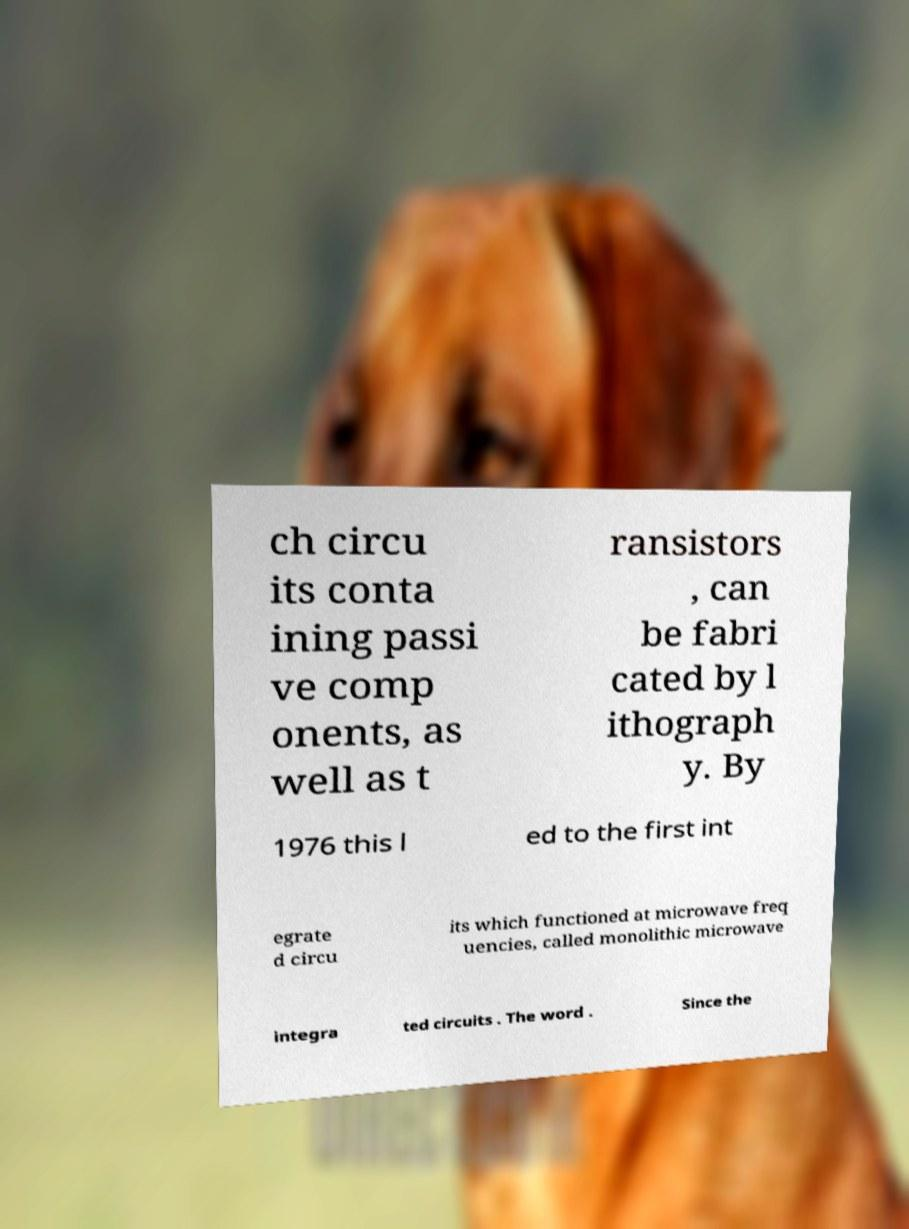For documentation purposes, I need the text within this image transcribed. Could you provide that? ch circu its conta ining passi ve comp onents, as well as t ransistors , can be fabri cated by l ithograph y. By 1976 this l ed to the first int egrate d circu its which functioned at microwave freq uencies, called monolithic microwave integra ted circuits . The word . Since the 